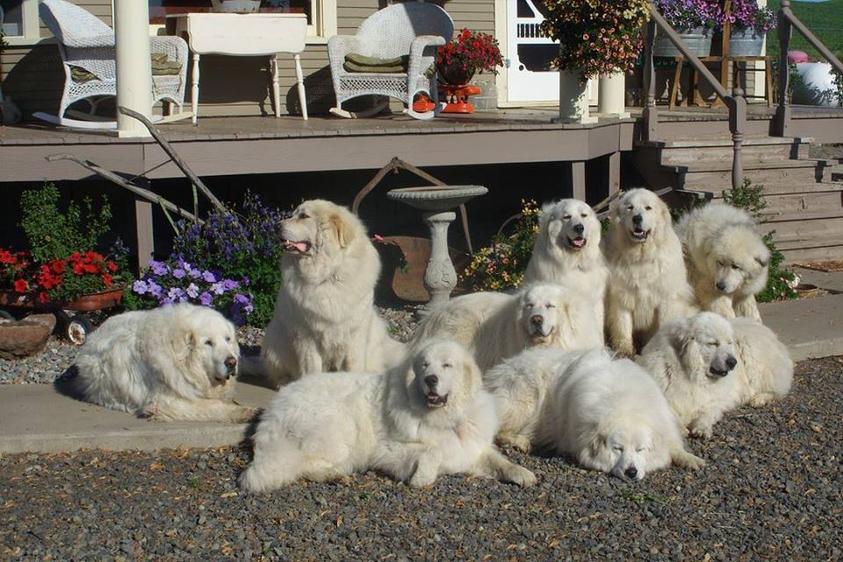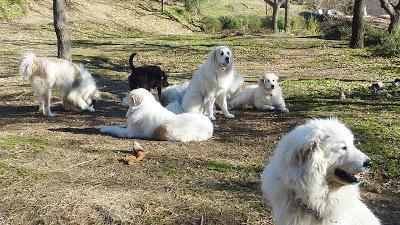The first image is the image on the left, the second image is the image on the right. For the images shown, is this caption "At least one white dog is in a scene with goats, and a fence is present in each image." true? Answer yes or no. No. The first image is the image on the left, the second image is the image on the right. Evaluate the accuracy of this statement regarding the images: "There is a picture of a dog and a goat together.". Is it true? Answer yes or no. No. 